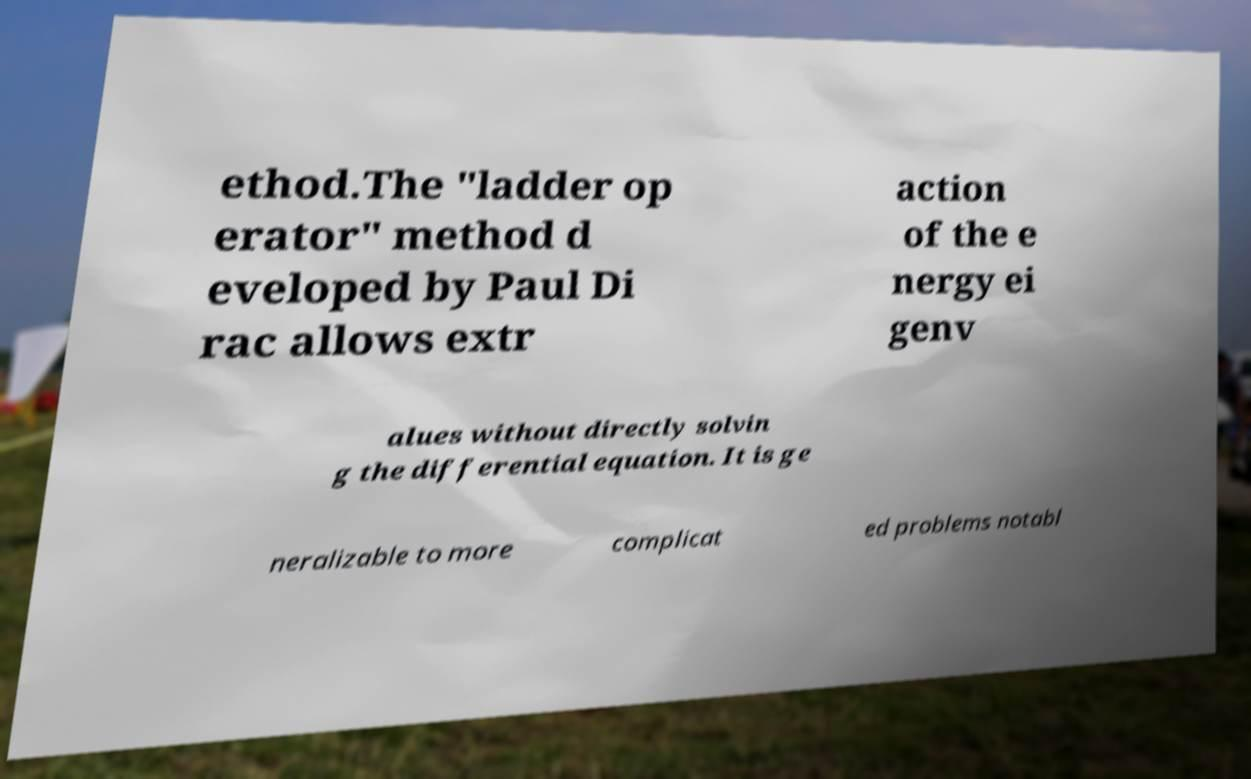There's text embedded in this image that I need extracted. Can you transcribe it verbatim? ethod.The "ladder op erator" method d eveloped by Paul Di rac allows extr action of the e nergy ei genv alues without directly solvin g the differential equation. It is ge neralizable to more complicat ed problems notabl 